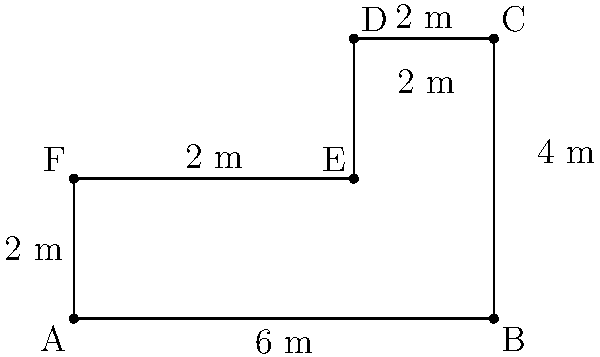As a criminal defense attorney, you're reviewing a crime scene sketch provided by the prosecution. The sketch shows an irregularly shaped room where the alleged crime took place. Calculate the total area of the crime scene to help determine if there was enough space for the events described by the prosecution to have occurred as claimed. To calculate the area of this irregular shape, we can break it down into rectangles:

1. First, identify two rectangles:
   - Rectangle 1: ABCF (6m x 2m)
   - Rectangle 2: DEFC (2m x 2m)

2. Calculate the area of Rectangle 1:
   $A_1 = 6m \times 2m = 12m^2$

3. Calculate the area of Rectangle 2:
   $A_2 = 2m \times 2m = 4m^2$

4. Sum up the areas:
   $A_{total} = A_1 + A_2 = 12m^2 + 4m^2 = 16m^2$

Therefore, the total area of the crime scene is 16 square meters.
Answer: 16 $m^2$ 